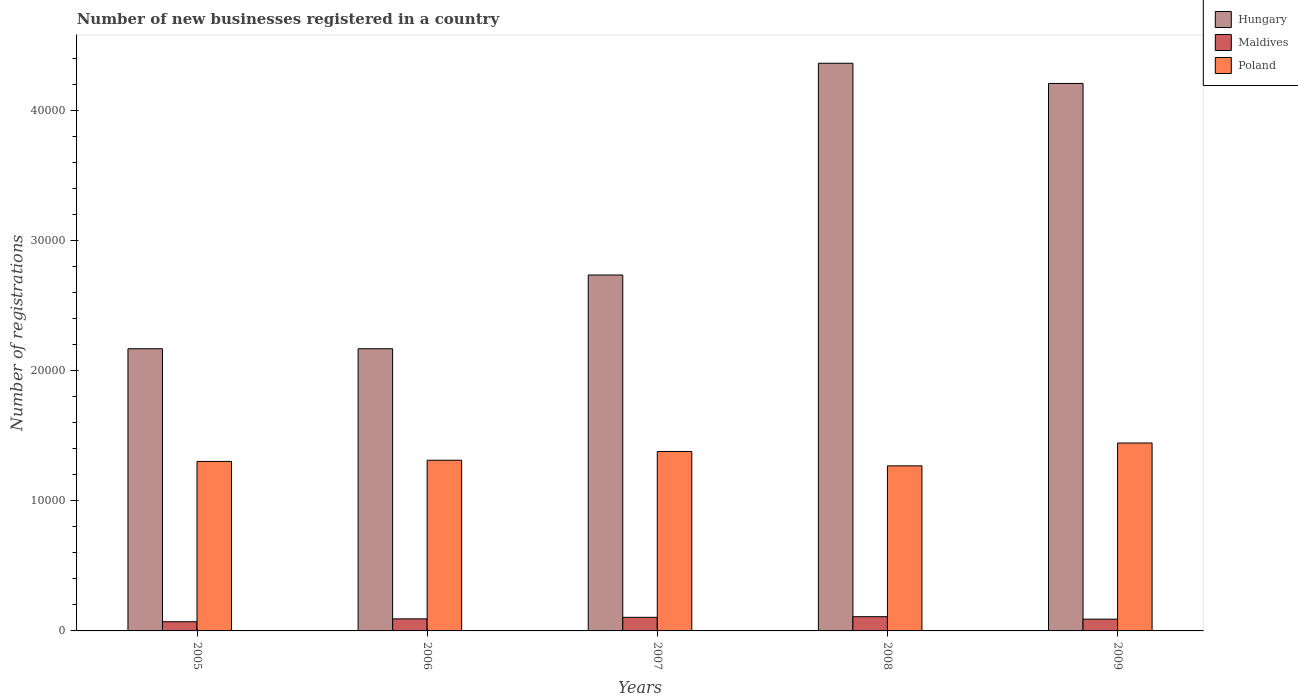How many different coloured bars are there?
Ensure brevity in your answer.  3. Are the number of bars on each tick of the X-axis equal?
Your answer should be very brief. Yes. How many bars are there on the 3rd tick from the left?
Ensure brevity in your answer.  3. In how many cases, is the number of bars for a given year not equal to the number of legend labels?
Keep it short and to the point. 0. What is the number of new businesses registered in Hungary in 2005?
Provide a succinct answer. 2.17e+04. Across all years, what is the maximum number of new businesses registered in Maldives?
Offer a terse response. 1092. Across all years, what is the minimum number of new businesses registered in Poland?
Keep it short and to the point. 1.27e+04. What is the total number of new businesses registered in Hungary in the graph?
Your answer should be very brief. 1.56e+05. What is the difference between the number of new businesses registered in Maldives in 2005 and that in 2008?
Provide a succinct answer. -387. What is the difference between the number of new businesses registered in Poland in 2005 and the number of new businesses registered in Hungary in 2006?
Ensure brevity in your answer.  -8654. What is the average number of new businesses registered in Maldives per year?
Your response must be concise. 934. In the year 2005, what is the difference between the number of new businesses registered in Maldives and number of new businesses registered in Hungary?
Make the answer very short. -2.10e+04. What is the ratio of the number of new businesses registered in Hungary in 2007 to that in 2009?
Ensure brevity in your answer.  0.65. Is the difference between the number of new businesses registered in Maldives in 2005 and 2009 greater than the difference between the number of new businesses registered in Hungary in 2005 and 2009?
Provide a succinct answer. Yes. What is the difference between the highest and the lowest number of new businesses registered in Hungary?
Offer a very short reply. 2.19e+04. Is the sum of the number of new businesses registered in Poland in 2005 and 2009 greater than the maximum number of new businesses registered in Maldives across all years?
Your answer should be compact. Yes. What does the 1st bar from the left in 2005 represents?
Make the answer very short. Hungary. What does the 2nd bar from the right in 2006 represents?
Your response must be concise. Maldives. How many bars are there?
Give a very brief answer. 15. How many years are there in the graph?
Keep it short and to the point. 5. What is the difference between two consecutive major ticks on the Y-axis?
Your answer should be compact. 10000. Where does the legend appear in the graph?
Keep it short and to the point. Top right. How many legend labels are there?
Provide a succinct answer. 3. How are the legend labels stacked?
Provide a short and direct response. Vertical. What is the title of the graph?
Offer a very short reply. Number of new businesses registered in a country. Does "Canada" appear as one of the legend labels in the graph?
Provide a short and direct response. No. What is the label or title of the X-axis?
Your answer should be compact. Years. What is the label or title of the Y-axis?
Provide a succinct answer. Number of registrations. What is the Number of registrations of Hungary in 2005?
Offer a very short reply. 2.17e+04. What is the Number of registrations of Maldives in 2005?
Keep it short and to the point. 705. What is the Number of registrations of Poland in 2005?
Your answer should be compact. 1.30e+04. What is the Number of registrations of Hungary in 2006?
Your answer should be very brief. 2.17e+04. What is the Number of registrations in Maldives in 2006?
Your answer should be very brief. 926. What is the Number of registrations of Poland in 2006?
Ensure brevity in your answer.  1.31e+04. What is the Number of registrations of Hungary in 2007?
Provide a short and direct response. 2.73e+04. What is the Number of registrations of Maldives in 2007?
Keep it short and to the point. 1043. What is the Number of registrations in Poland in 2007?
Your response must be concise. 1.38e+04. What is the Number of registrations in Hungary in 2008?
Give a very brief answer. 4.36e+04. What is the Number of registrations of Maldives in 2008?
Your answer should be compact. 1092. What is the Number of registrations of Poland in 2008?
Your answer should be very brief. 1.27e+04. What is the Number of registrations in Hungary in 2009?
Provide a succinct answer. 4.20e+04. What is the Number of registrations of Maldives in 2009?
Offer a terse response. 904. What is the Number of registrations of Poland in 2009?
Make the answer very short. 1.44e+04. Across all years, what is the maximum Number of registrations of Hungary?
Offer a terse response. 4.36e+04. Across all years, what is the maximum Number of registrations in Maldives?
Offer a terse response. 1092. Across all years, what is the maximum Number of registrations in Poland?
Make the answer very short. 1.44e+04. Across all years, what is the minimum Number of registrations of Hungary?
Provide a succinct answer. 2.17e+04. Across all years, what is the minimum Number of registrations in Maldives?
Your answer should be very brief. 705. Across all years, what is the minimum Number of registrations in Poland?
Provide a succinct answer. 1.27e+04. What is the total Number of registrations in Hungary in the graph?
Offer a very short reply. 1.56e+05. What is the total Number of registrations of Maldives in the graph?
Give a very brief answer. 4670. What is the total Number of registrations of Poland in the graph?
Your answer should be compact. 6.70e+04. What is the difference between the Number of registrations in Maldives in 2005 and that in 2006?
Make the answer very short. -221. What is the difference between the Number of registrations in Poland in 2005 and that in 2006?
Offer a terse response. -92. What is the difference between the Number of registrations of Hungary in 2005 and that in 2007?
Offer a very short reply. -5663. What is the difference between the Number of registrations of Maldives in 2005 and that in 2007?
Provide a succinct answer. -338. What is the difference between the Number of registrations in Poland in 2005 and that in 2007?
Offer a very short reply. -763. What is the difference between the Number of registrations of Hungary in 2005 and that in 2008?
Make the answer very short. -2.19e+04. What is the difference between the Number of registrations of Maldives in 2005 and that in 2008?
Keep it short and to the point. -387. What is the difference between the Number of registrations in Poland in 2005 and that in 2008?
Your answer should be compact. 340. What is the difference between the Number of registrations in Hungary in 2005 and that in 2009?
Make the answer very short. -2.04e+04. What is the difference between the Number of registrations in Maldives in 2005 and that in 2009?
Offer a very short reply. -199. What is the difference between the Number of registrations in Poland in 2005 and that in 2009?
Give a very brief answer. -1416. What is the difference between the Number of registrations of Hungary in 2006 and that in 2007?
Provide a short and direct response. -5663. What is the difference between the Number of registrations in Maldives in 2006 and that in 2007?
Give a very brief answer. -117. What is the difference between the Number of registrations in Poland in 2006 and that in 2007?
Offer a terse response. -671. What is the difference between the Number of registrations in Hungary in 2006 and that in 2008?
Your response must be concise. -2.19e+04. What is the difference between the Number of registrations in Maldives in 2006 and that in 2008?
Offer a very short reply. -166. What is the difference between the Number of registrations of Poland in 2006 and that in 2008?
Offer a very short reply. 432. What is the difference between the Number of registrations in Hungary in 2006 and that in 2009?
Make the answer very short. -2.04e+04. What is the difference between the Number of registrations in Poland in 2006 and that in 2009?
Make the answer very short. -1324. What is the difference between the Number of registrations of Hungary in 2007 and that in 2008?
Keep it short and to the point. -1.63e+04. What is the difference between the Number of registrations in Maldives in 2007 and that in 2008?
Offer a very short reply. -49. What is the difference between the Number of registrations in Poland in 2007 and that in 2008?
Offer a terse response. 1103. What is the difference between the Number of registrations of Hungary in 2007 and that in 2009?
Offer a very short reply. -1.47e+04. What is the difference between the Number of registrations in Maldives in 2007 and that in 2009?
Make the answer very short. 139. What is the difference between the Number of registrations in Poland in 2007 and that in 2009?
Give a very brief answer. -653. What is the difference between the Number of registrations in Hungary in 2008 and that in 2009?
Ensure brevity in your answer.  1552. What is the difference between the Number of registrations in Maldives in 2008 and that in 2009?
Your answer should be very brief. 188. What is the difference between the Number of registrations in Poland in 2008 and that in 2009?
Ensure brevity in your answer.  -1756. What is the difference between the Number of registrations in Hungary in 2005 and the Number of registrations in Maldives in 2006?
Your answer should be very brief. 2.07e+04. What is the difference between the Number of registrations of Hungary in 2005 and the Number of registrations of Poland in 2006?
Your answer should be compact. 8562. What is the difference between the Number of registrations in Maldives in 2005 and the Number of registrations in Poland in 2006?
Make the answer very short. -1.24e+04. What is the difference between the Number of registrations in Hungary in 2005 and the Number of registrations in Maldives in 2007?
Offer a very short reply. 2.06e+04. What is the difference between the Number of registrations in Hungary in 2005 and the Number of registrations in Poland in 2007?
Keep it short and to the point. 7891. What is the difference between the Number of registrations of Maldives in 2005 and the Number of registrations of Poland in 2007?
Provide a succinct answer. -1.31e+04. What is the difference between the Number of registrations in Hungary in 2005 and the Number of registrations in Maldives in 2008?
Your answer should be compact. 2.06e+04. What is the difference between the Number of registrations in Hungary in 2005 and the Number of registrations in Poland in 2008?
Your answer should be compact. 8994. What is the difference between the Number of registrations in Maldives in 2005 and the Number of registrations in Poland in 2008?
Your response must be concise. -1.20e+04. What is the difference between the Number of registrations of Hungary in 2005 and the Number of registrations of Maldives in 2009?
Keep it short and to the point. 2.08e+04. What is the difference between the Number of registrations of Hungary in 2005 and the Number of registrations of Poland in 2009?
Provide a short and direct response. 7238. What is the difference between the Number of registrations of Maldives in 2005 and the Number of registrations of Poland in 2009?
Ensure brevity in your answer.  -1.37e+04. What is the difference between the Number of registrations of Hungary in 2006 and the Number of registrations of Maldives in 2007?
Keep it short and to the point. 2.06e+04. What is the difference between the Number of registrations of Hungary in 2006 and the Number of registrations of Poland in 2007?
Offer a very short reply. 7891. What is the difference between the Number of registrations in Maldives in 2006 and the Number of registrations in Poland in 2007?
Keep it short and to the point. -1.29e+04. What is the difference between the Number of registrations in Hungary in 2006 and the Number of registrations in Maldives in 2008?
Keep it short and to the point. 2.06e+04. What is the difference between the Number of registrations of Hungary in 2006 and the Number of registrations of Poland in 2008?
Your answer should be compact. 8994. What is the difference between the Number of registrations in Maldives in 2006 and the Number of registrations in Poland in 2008?
Offer a very short reply. -1.18e+04. What is the difference between the Number of registrations in Hungary in 2006 and the Number of registrations in Maldives in 2009?
Make the answer very short. 2.08e+04. What is the difference between the Number of registrations in Hungary in 2006 and the Number of registrations in Poland in 2009?
Give a very brief answer. 7238. What is the difference between the Number of registrations in Maldives in 2006 and the Number of registrations in Poland in 2009?
Offer a terse response. -1.35e+04. What is the difference between the Number of registrations of Hungary in 2007 and the Number of registrations of Maldives in 2008?
Your answer should be very brief. 2.62e+04. What is the difference between the Number of registrations of Hungary in 2007 and the Number of registrations of Poland in 2008?
Ensure brevity in your answer.  1.47e+04. What is the difference between the Number of registrations in Maldives in 2007 and the Number of registrations in Poland in 2008?
Provide a succinct answer. -1.16e+04. What is the difference between the Number of registrations of Hungary in 2007 and the Number of registrations of Maldives in 2009?
Provide a succinct answer. 2.64e+04. What is the difference between the Number of registrations in Hungary in 2007 and the Number of registrations in Poland in 2009?
Offer a terse response. 1.29e+04. What is the difference between the Number of registrations in Maldives in 2007 and the Number of registrations in Poland in 2009?
Provide a succinct answer. -1.34e+04. What is the difference between the Number of registrations of Hungary in 2008 and the Number of registrations of Maldives in 2009?
Keep it short and to the point. 4.27e+04. What is the difference between the Number of registrations of Hungary in 2008 and the Number of registrations of Poland in 2009?
Your response must be concise. 2.92e+04. What is the difference between the Number of registrations of Maldives in 2008 and the Number of registrations of Poland in 2009?
Your answer should be very brief. -1.33e+04. What is the average Number of registrations of Hungary per year?
Ensure brevity in your answer.  3.13e+04. What is the average Number of registrations in Maldives per year?
Your answer should be very brief. 934. What is the average Number of registrations in Poland per year?
Offer a very short reply. 1.34e+04. In the year 2005, what is the difference between the Number of registrations in Hungary and Number of registrations in Maldives?
Offer a very short reply. 2.10e+04. In the year 2005, what is the difference between the Number of registrations in Hungary and Number of registrations in Poland?
Give a very brief answer. 8654. In the year 2005, what is the difference between the Number of registrations in Maldives and Number of registrations in Poland?
Your answer should be very brief. -1.23e+04. In the year 2006, what is the difference between the Number of registrations in Hungary and Number of registrations in Maldives?
Ensure brevity in your answer.  2.07e+04. In the year 2006, what is the difference between the Number of registrations of Hungary and Number of registrations of Poland?
Provide a succinct answer. 8562. In the year 2006, what is the difference between the Number of registrations of Maldives and Number of registrations of Poland?
Your answer should be compact. -1.22e+04. In the year 2007, what is the difference between the Number of registrations in Hungary and Number of registrations in Maldives?
Your answer should be compact. 2.63e+04. In the year 2007, what is the difference between the Number of registrations in Hungary and Number of registrations in Poland?
Provide a short and direct response. 1.36e+04. In the year 2007, what is the difference between the Number of registrations in Maldives and Number of registrations in Poland?
Make the answer very short. -1.27e+04. In the year 2008, what is the difference between the Number of registrations of Hungary and Number of registrations of Maldives?
Ensure brevity in your answer.  4.25e+04. In the year 2008, what is the difference between the Number of registrations of Hungary and Number of registrations of Poland?
Offer a very short reply. 3.09e+04. In the year 2008, what is the difference between the Number of registrations in Maldives and Number of registrations in Poland?
Provide a succinct answer. -1.16e+04. In the year 2009, what is the difference between the Number of registrations in Hungary and Number of registrations in Maldives?
Offer a terse response. 4.11e+04. In the year 2009, what is the difference between the Number of registrations of Hungary and Number of registrations of Poland?
Make the answer very short. 2.76e+04. In the year 2009, what is the difference between the Number of registrations in Maldives and Number of registrations in Poland?
Ensure brevity in your answer.  -1.35e+04. What is the ratio of the Number of registrations of Hungary in 2005 to that in 2006?
Keep it short and to the point. 1. What is the ratio of the Number of registrations in Maldives in 2005 to that in 2006?
Your response must be concise. 0.76. What is the ratio of the Number of registrations of Poland in 2005 to that in 2006?
Keep it short and to the point. 0.99. What is the ratio of the Number of registrations of Hungary in 2005 to that in 2007?
Provide a succinct answer. 0.79. What is the ratio of the Number of registrations of Maldives in 2005 to that in 2007?
Make the answer very short. 0.68. What is the ratio of the Number of registrations in Poland in 2005 to that in 2007?
Offer a very short reply. 0.94. What is the ratio of the Number of registrations of Hungary in 2005 to that in 2008?
Offer a terse response. 0.5. What is the ratio of the Number of registrations in Maldives in 2005 to that in 2008?
Your response must be concise. 0.65. What is the ratio of the Number of registrations in Poland in 2005 to that in 2008?
Provide a short and direct response. 1.03. What is the ratio of the Number of registrations in Hungary in 2005 to that in 2009?
Provide a succinct answer. 0.52. What is the ratio of the Number of registrations of Maldives in 2005 to that in 2009?
Give a very brief answer. 0.78. What is the ratio of the Number of registrations in Poland in 2005 to that in 2009?
Provide a succinct answer. 0.9. What is the ratio of the Number of registrations of Hungary in 2006 to that in 2007?
Ensure brevity in your answer.  0.79. What is the ratio of the Number of registrations of Maldives in 2006 to that in 2007?
Your response must be concise. 0.89. What is the ratio of the Number of registrations of Poland in 2006 to that in 2007?
Your answer should be compact. 0.95. What is the ratio of the Number of registrations in Hungary in 2006 to that in 2008?
Provide a short and direct response. 0.5. What is the ratio of the Number of registrations of Maldives in 2006 to that in 2008?
Your response must be concise. 0.85. What is the ratio of the Number of registrations of Poland in 2006 to that in 2008?
Your response must be concise. 1.03. What is the ratio of the Number of registrations in Hungary in 2006 to that in 2009?
Your answer should be compact. 0.52. What is the ratio of the Number of registrations of Maldives in 2006 to that in 2009?
Your answer should be very brief. 1.02. What is the ratio of the Number of registrations in Poland in 2006 to that in 2009?
Offer a terse response. 0.91. What is the ratio of the Number of registrations in Hungary in 2007 to that in 2008?
Provide a short and direct response. 0.63. What is the ratio of the Number of registrations of Maldives in 2007 to that in 2008?
Your answer should be compact. 0.96. What is the ratio of the Number of registrations of Poland in 2007 to that in 2008?
Make the answer very short. 1.09. What is the ratio of the Number of registrations in Hungary in 2007 to that in 2009?
Your response must be concise. 0.65. What is the ratio of the Number of registrations of Maldives in 2007 to that in 2009?
Offer a very short reply. 1.15. What is the ratio of the Number of registrations of Poland in 2007 to that in 2009?
Your response must be concise. 0.95. What is the ratio of the Number of registrations in Hungary in 2008 to that in 2009?
Your response must be concise. 1.04. What is the ratio of the Number of registrations in Maldives in 2008 to that in 2009?
Offer a very short reply. 1.21. What is the ratio of the Number of registrations of Poland in 2008 to that in 2009?
Ensure brevity in your answer.  0.88. What is the difference between the highest and the second highest Number of registrations in Hungary?
Your answer should be very brief. 1552. What is the difference between the highest and the second highest Number of registrations of Maldives?
Make the answer very short. 49. What is the difference between the highest and the second highest Number of registrations in Poland?
Ensure brevity in your answer.  653. What is the difference between the highest and the lowest Number of registrations of Hungary?
Your response must be concise. 2.19e+04. What is the difference between the highest and the lowest Number of registrations of Maldives?
Offer a terse response. 387. What is the difference between the highest and the lowest Number of registrations of Poland?
Keep it short and to the point. 1756. 